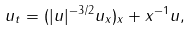<formula> <loc_0><loc_0><loc_500><loc_500>u _ { t } = ( | u | ^ { - 3 / 2 } u _ { x } ) _ { x } + x ^ { - 1 } u ,</formula> 